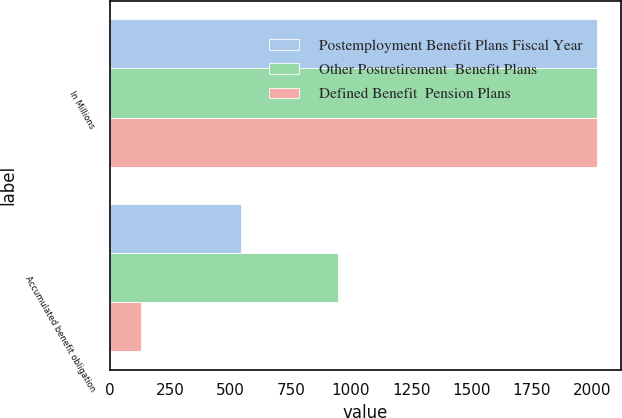Convert chart. <chart><loc_0><loc_0><loc_500><loc_500><stacked_bar_chart><ecel><fcel>In Millions<fcel>Accumulated benefit obligation<nl><fcel>Postemployment Benefit Plans Fiscal Year<fcel>2017<fcel>542.3<nl><fcel>Other Postretirement  Benefit Plans<fcel>2017<fcel>947.9<nl><fcel>Defined Benefit  Pension Plans<fcel>2017<fcel>130.1<nl></chart> 